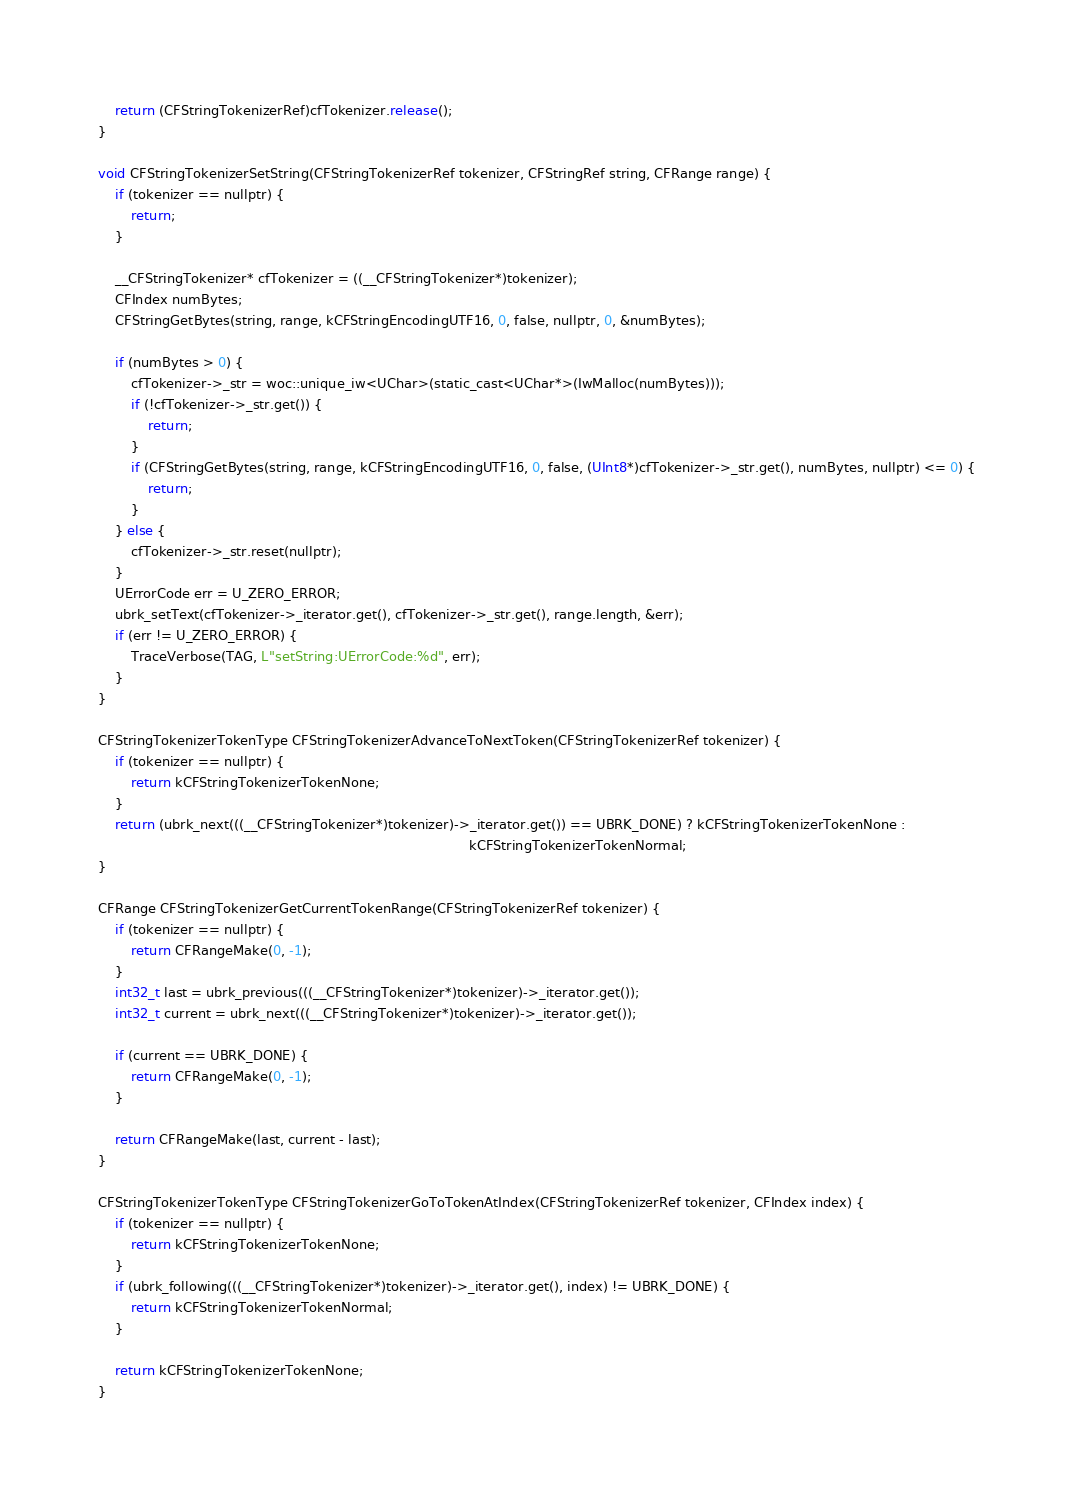<code> <loc_0><loc_0><loc_500><loc_500><_ObjectiveC_>
    return (CFStringTokenizerRef)cfTokenizer.release();
}

void CFStringTokenizerSetString(CFStringTokenizerRef tokenizer, CFStringRef string, CFRange range) {
    if (tokenizer == nullptr) {
        return;
    }

    __CFStringTokenizer* cfTokenizer = ((__CFStringTokenizer*)tokenizer);
    CFIndex numBytes;
    CFStringGetBytes(string, range, kCFStringEncodingUTF16, 0, false, nullptr, 0, &numBytes);

    if (numBytes > 0) {
        cfTokenizer->_str = woc::unique_iw<UChar>(static_cast<UChar*>(IwMalloc(numBytes)));
        if (!cfTokenizer->_str.get()) {
            return;
        }
        if (CFStringGetBytes(string, range, kCFStringEncodingUTF16, 0, false, (UInt8*)cfTokenizer->_str.get(), numBytes, nullptr) <= 0) {
            return;
        }
    } else {
        cfTokenizer->_str.reset(nullptr);
    }
    UErrorCode err = U_ZERO_ERROR;
    ubrk_setText(cfTokenizer->_iterator.get(), cfTokenizer->_str.get(), range.length, &err);
    if (err != U_ZERO_ERROR) {
        TraceVerbose(TAG, L"setString:UErrorCode:%d", err);
    }
}

CFStringTokenizerTokenType CFStringTokenizerAdvanceToNextToken(CFStringTokenizerRef tokenizer) {
    if (tokenizer == nullptr) {
        return kCFStringTokenizerTokenNone;
    }
    return (ubrk_next(((__CFStringTokenizer*)tokenizer)->_iterator.get()) == UBRK_DONE) ? kCFStringTokenizerTokenNone :
                                                                                          kCFStringTokenizerTokenNormal;
}

CFRange CFStringTokenizerGetCurrentTokenRange(CFStringTokenizerRef tokenizer) {
    if (tokenizer == nullptr) {
        return CFRangeMake(0, -1);
    }
    int32_t last = ubrk_previous(((__CFStringTokenizer*)tokenizer)->_iterator.get());
    int32_t current = ubrk_next(((__CFStringTokenizer*)tokenizer)->_iterator.get());

    if (current == UBRK_DONE) {
        return CFRangeMake(0, -1);
    }

    return CFRangeMake(last, current - last);
}

CFStringTokenizerTokenType CFStringTokenizerGoToTokenAtIndex(CFStringTokenizerRef tokenizer, CFIndex index) {
    if (tokenizer == nullptr) {
        return kCFStringTokenizerTokenNone;
    }
    if (ubrk_following(((__CFStringTokenizer*)tokenizer)->_iterator.get(), index) != UBRK_DONE) {
        return kCFStringTokenizerTokenNormal;
    }

    return kCFStringTokenizerTokenNone;
}</code> 